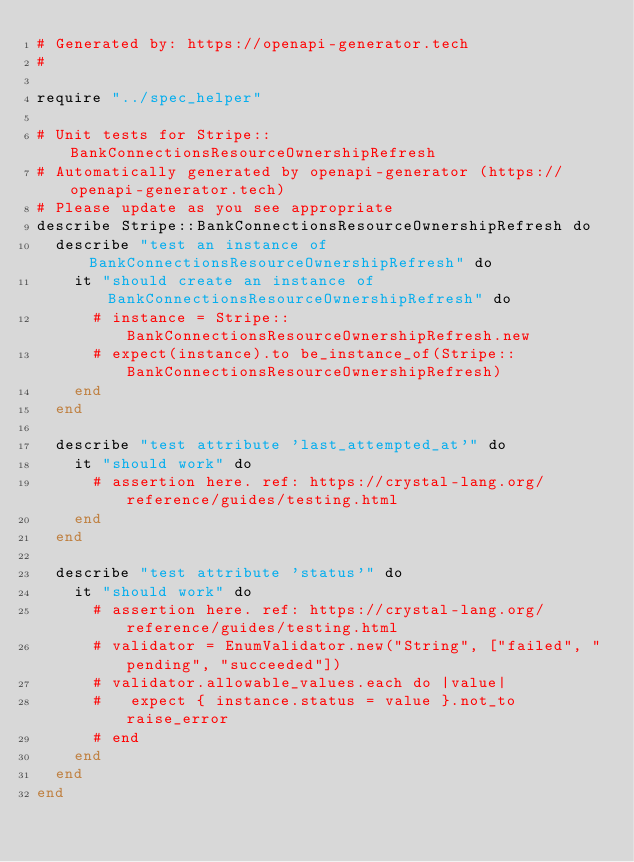<code> <loc_0><loc_0><loc_500><loc_500><_Crystal_># Generated by: https://openapi-generator.tech
#

require "../spec_helper"

# Unit tests for Stripe::BankConnectionsResourceOwnershipRefresh
# Automatically generated by openapi-generator (https://openapi-generator.tech)
# Please update as you see appropriate
describe Stripe::BankConnectionsResourceOwnershipRefresh do
  describe "test an instance of BankConnectionsResourceOwnershipRefresh" do
    it "should create an instance of BankConnectionsResourceOwnershipRefresh" do
      # instance = Stripe::BankConnectionsResourceOwnershipRefresh.new
      # expect(instance).to be_instance_of(Stripe::BankConnectionsResourceOwnershipRefresh)
    end
  end

  describe "test attribute 'last_attempted_at'" do
    it "should work" do
      # assertion here. ref: https://crystal-lang.org/reference/guides/testing.html
    end
  end

  describe "test attribute 'status'" do
    it "should work" do
      # assertion here. ref: https://crystal-lang.org/reference/guides/testing.html
      # validator = EnumValidator.new("String", ["failed", "pending", "succeeded"])
      # validator.allowable_values.each do |value|
      #   expect { instance.status = value }.not_to raise_error
      # end
    end
  end
end
</code> 